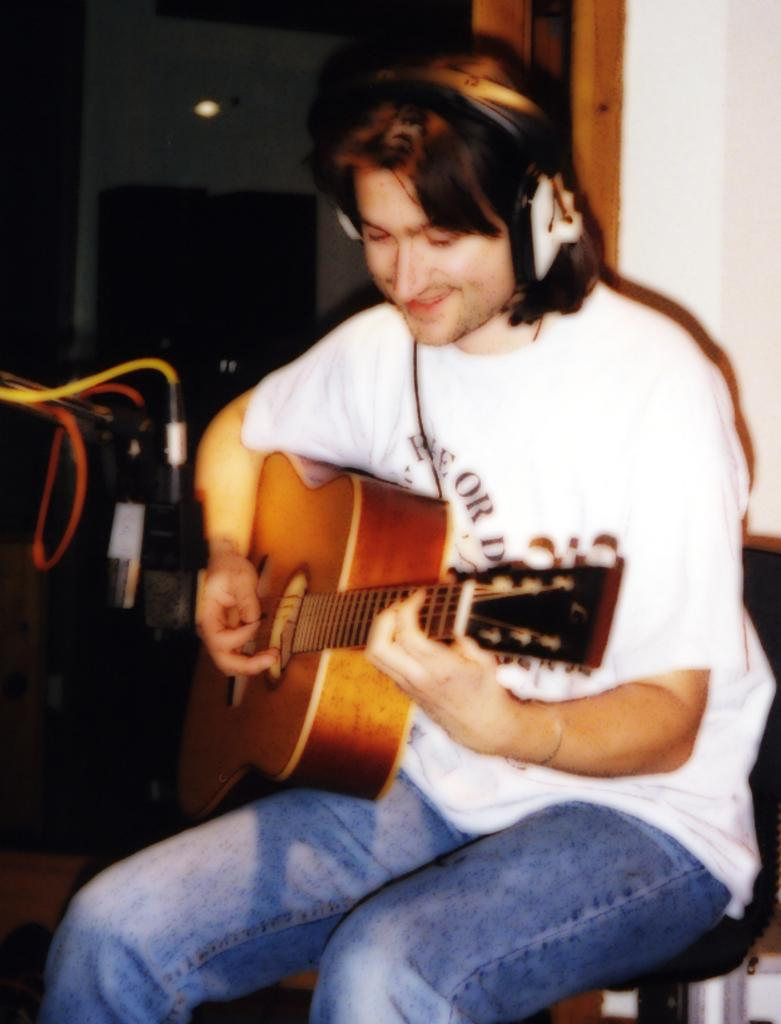Who is in the image? There is a man in the image. What is the man doing in the image? The man is sitting and playing the guitar. What is the man wearing while playing the guitar? The man is wearing earphones. What can be seen in the background of the image? There is a wall and a light in the background of the image. What type of prison is visible in the background of the image? There is no prison present in the image; it features a man sitting and playing the guitar with a wall and a light in the background. 